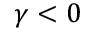Convert formula to latex. <formula><loc_0><loc_0><loc_500><loc_500>\gamma < 0</formula> 